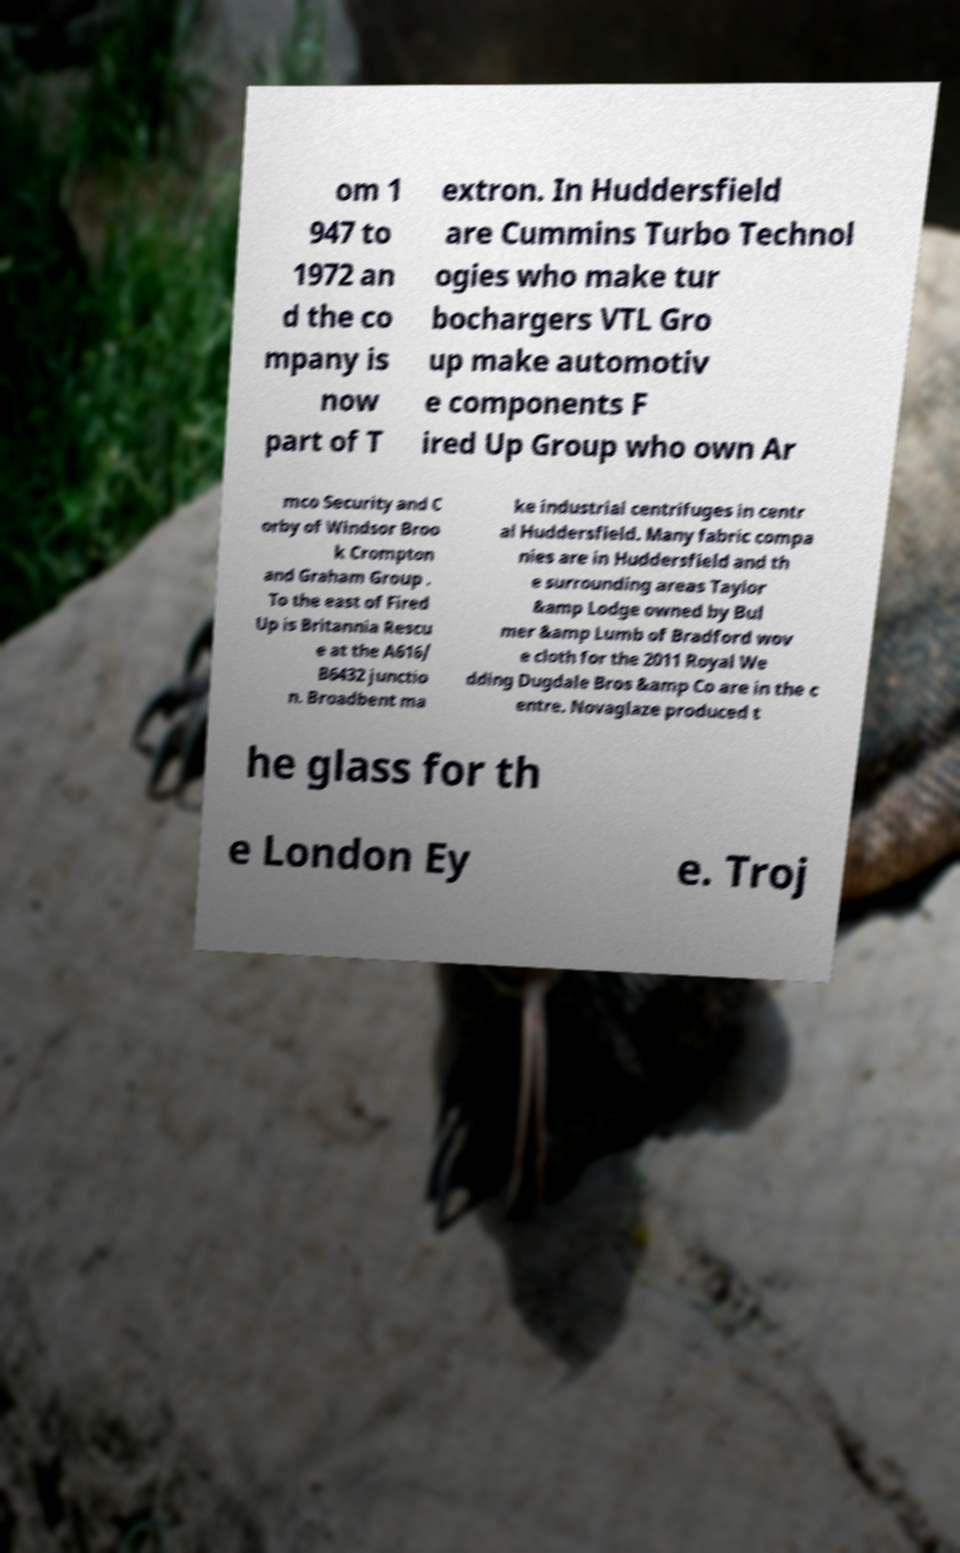There's text embedded in this image that I need extracted. Can you transcribe it verbatim? om 1 947 to 1972 an d the co mpany is now part of T extron. In Huddersfield are Cummins Turbo Technol ogies who make tur bochargers VTL Gro up make automotiv e components F ired Up Group who own Ar mco Security and C orby of Windsor Broo k Crompton and Graham Group . To the east of Fired Up is Britannia Rescu e at the A616/ B6432 junctio n. Broadbent ma ke industrial centrifuges in centr al Huddersfield. Many fabric compa nies are in Huddersfield and th e surrounding areas Taylor &amp Lodge owned by Bul mer &amp Lumb of Bradford wov e cloth for the 2011 Royal We dding Dugdale Bros &amp Co are in the c entre. Novaglaze produced t he glass for th e London Ey e. Troj 